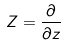<formula> <loc_0><loc_0><loc_500><loc_500>Z = \frac { \partial } { \partial z }</formula> 